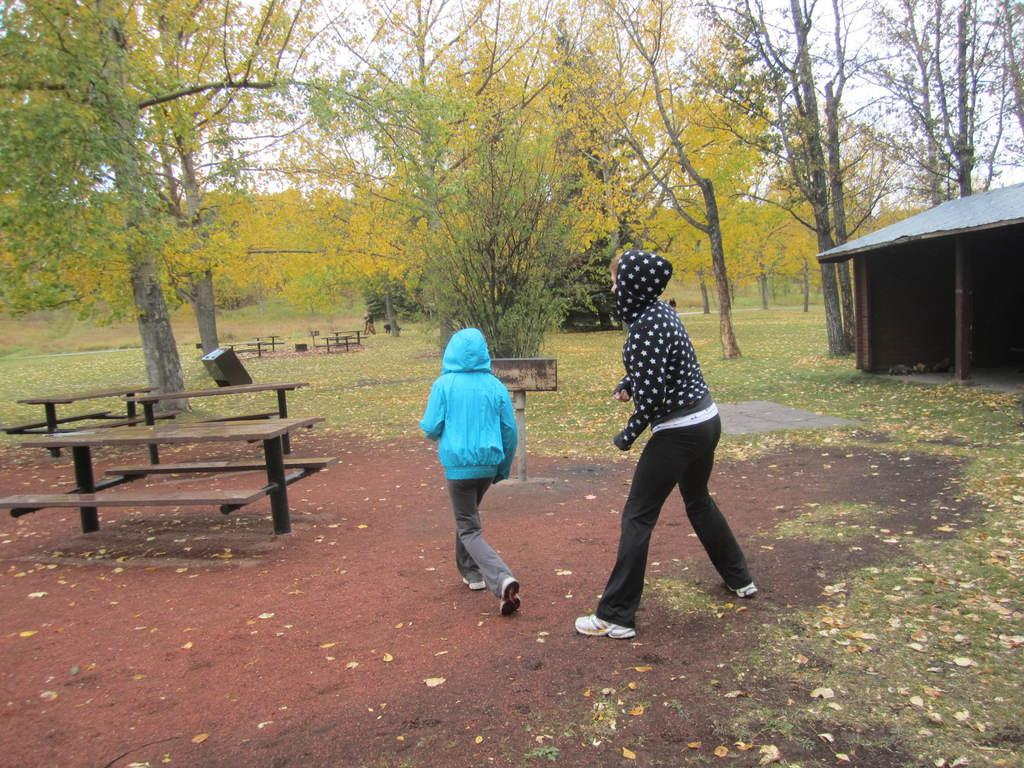How many people are in the image? There are two persons in the image. Where are the persons located in the image? The persons are on a path in the image. What type of seating is available in the image? There are benches in the image. What type of vegetation is visible in the image? There is grass visible in the image. What type of structure is present in the image? There is a shed in the image. What other natural elements are present in the image? There are trees in the image. What is the income of the persons in the image? There is no information about the income of the persons in the image. What type of beam is supporting the shed in the image? There is no information about the type of beam supporting the shed in the image. 